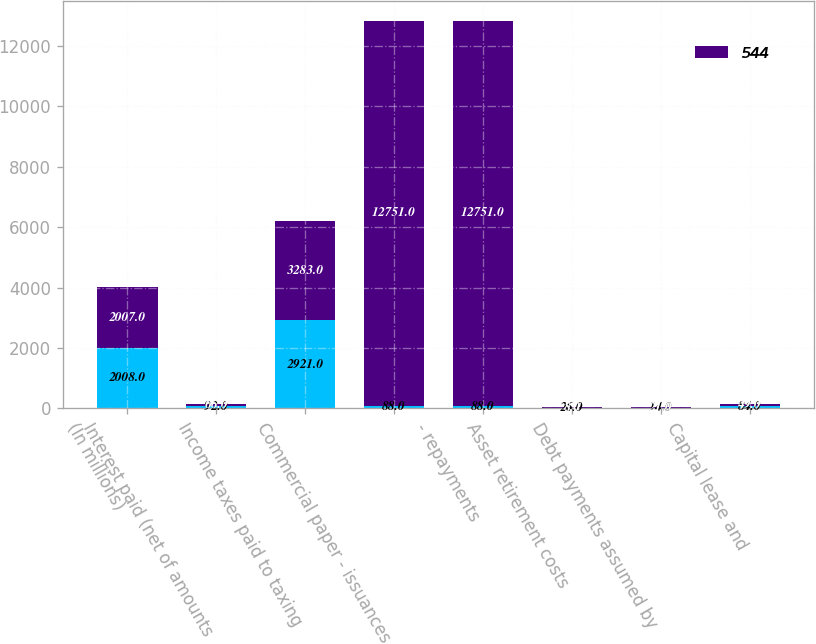<chart> <loc_0><loc_0><loc_500><loc_500><stacked_bar_chart><ecel><fcel>(In millions)<fcel>Interest paid (net of amounts<fcel>Income taxes paid to taxing<fcel>Commercial paper - issuances<fcel>- repayments<fcel>Asset retirement costs<fcel>Debt payments assumed by<fcel>Capital lease and<nl><fcel>nan<fcel>2008<fcel>92<fcel>2921<fcel>88<fcel>88<fcel>26<fcel>14<fcel>84<nl><fcel>544<fcel>2007<fcel>66<fcel>3283<fcel>12751<fcel>12751<fcel>8<fcel>21<fcel>49<nl></chart> 